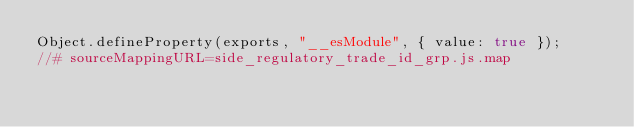Convert code to text. <code><loc_0><loc_0><loc_500><loc_500><_JavaScript_>Object.defineProperty(exports, "__esModule", { value: true });
//# sourceMappingURL=side_regulatory_trade_id_grp.js.map</code> 